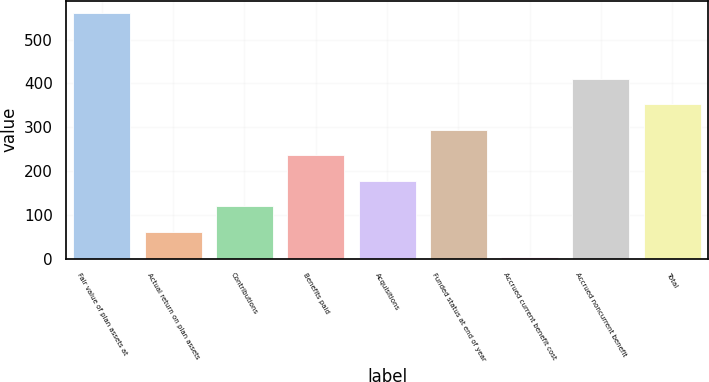Convert chart to OTSL. <chart><loc_0><loc_0><loc_500><loc_500><bar_chart><fcel>Fair value of plan assets at<fcel>Actual return on plan assets<fcel>Contributions<fcel>Benefits paid<fcel>Acquisitions<fcel>Funded status at end of year<fcel>Accrued current benefit cost<fcel>Accrued noncurrent benefit<fcel>Total<nl><fcel>560.3<fcel>61.41<fcel>119.52<fcel>235.74<fcel>177.63<fcel>293.85<fcel>3.3<fcel>410.07<fcel>351.96<nl></chart> 